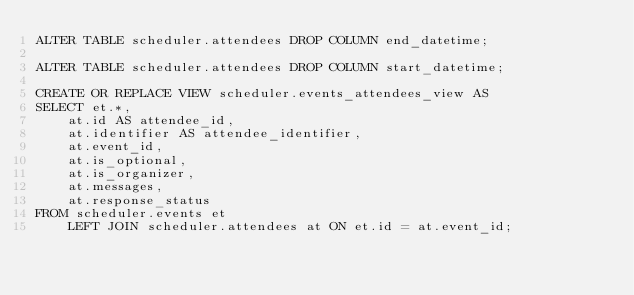<code> <loc_0><loc_0><loc_500><loc_500><_SQL_>ALTER TABLE scheduler.attendees DROP COLUMN end_datetime;

ALTER TABLE scheduler.attendees DROP COLUMN start_datetime;

CREATE OR REPLACE VIEW scheduler.events_attendees_view AS
SELECT et.*,
    at.id AS attendee_id,
    at.identifier AS attendee_identifier,
    at.event_id,
    at.is_optional,
    at.is_organizer,
    at.messages,
    at.response_status
FROM scheduler.events et
    LEFT JOIN scheduler.attendees at ON et.id = at.event_id;</code> 